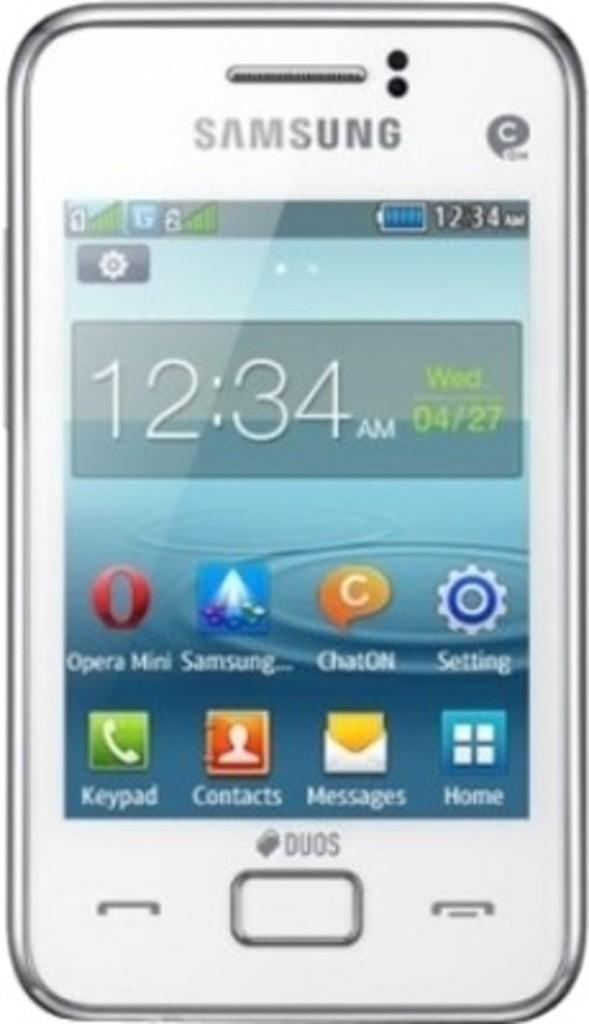What time is displayed on the phone?
Offer a terse response. 12:34. This is mobile phone?
Your answer should be very brief. Yes. 